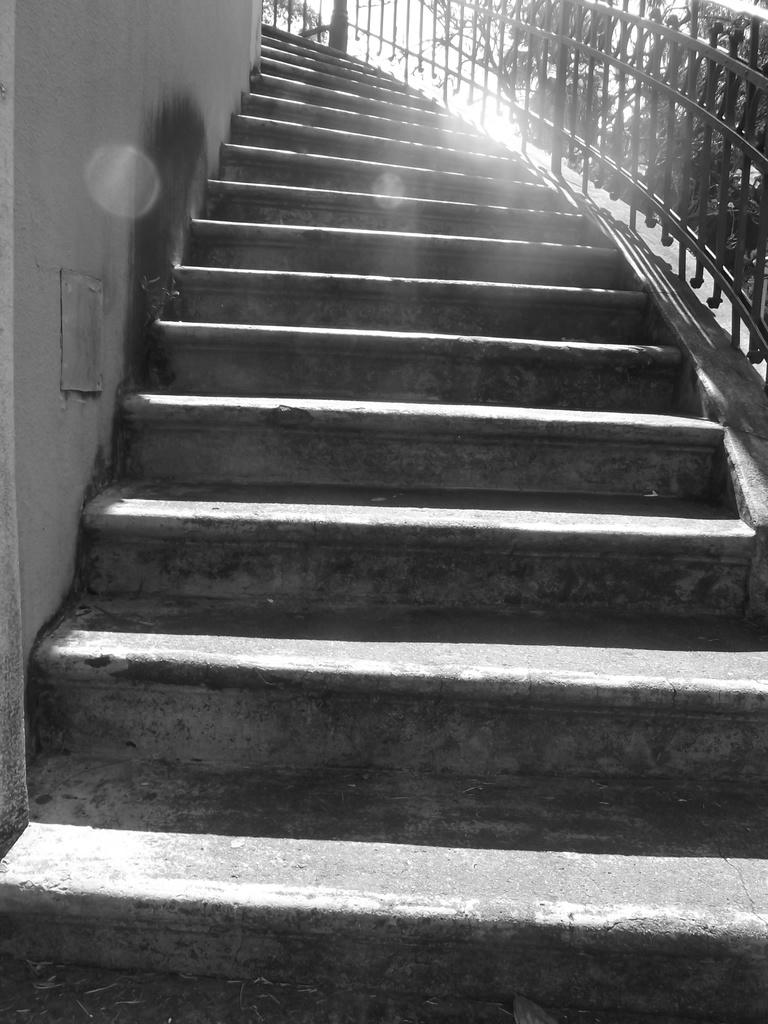What type of structure is present in the image? There is a staircase in the image. What feature is associated with the staircase? There is a railing in the image. What type of natural elements can be seen in the image? There are trees in the image. What is visible in the background of the image? The sky is visible in the image. What nation is represented by the flag on the railing in the image? There is no flag present on the railing in the image. 